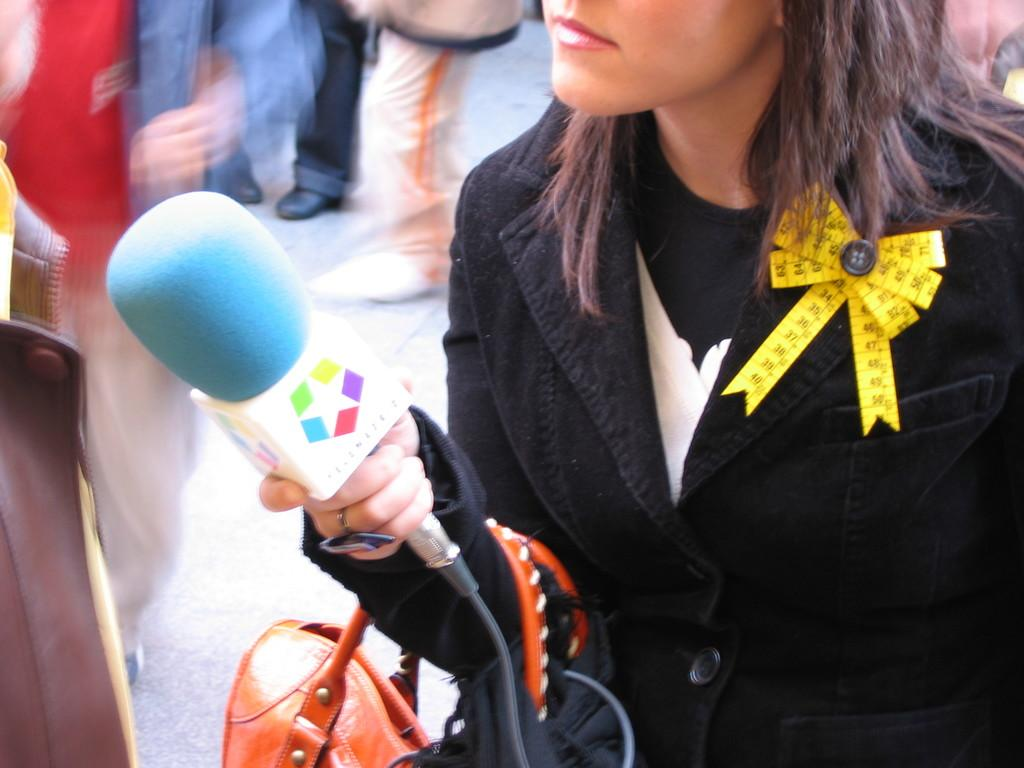Who is the main subject in the image? There is a woman in the image. What is the woman doing in the image? The woman is standing and holding a microphone in her hand. What can be seen in the background of the image? There is a group of people standing on the road in the background of the image. What type of pickle is being used as a prop by the woman in the image? There is no pickle present in the image. Where is the station located in the image? There is no mention of a station in the image. 